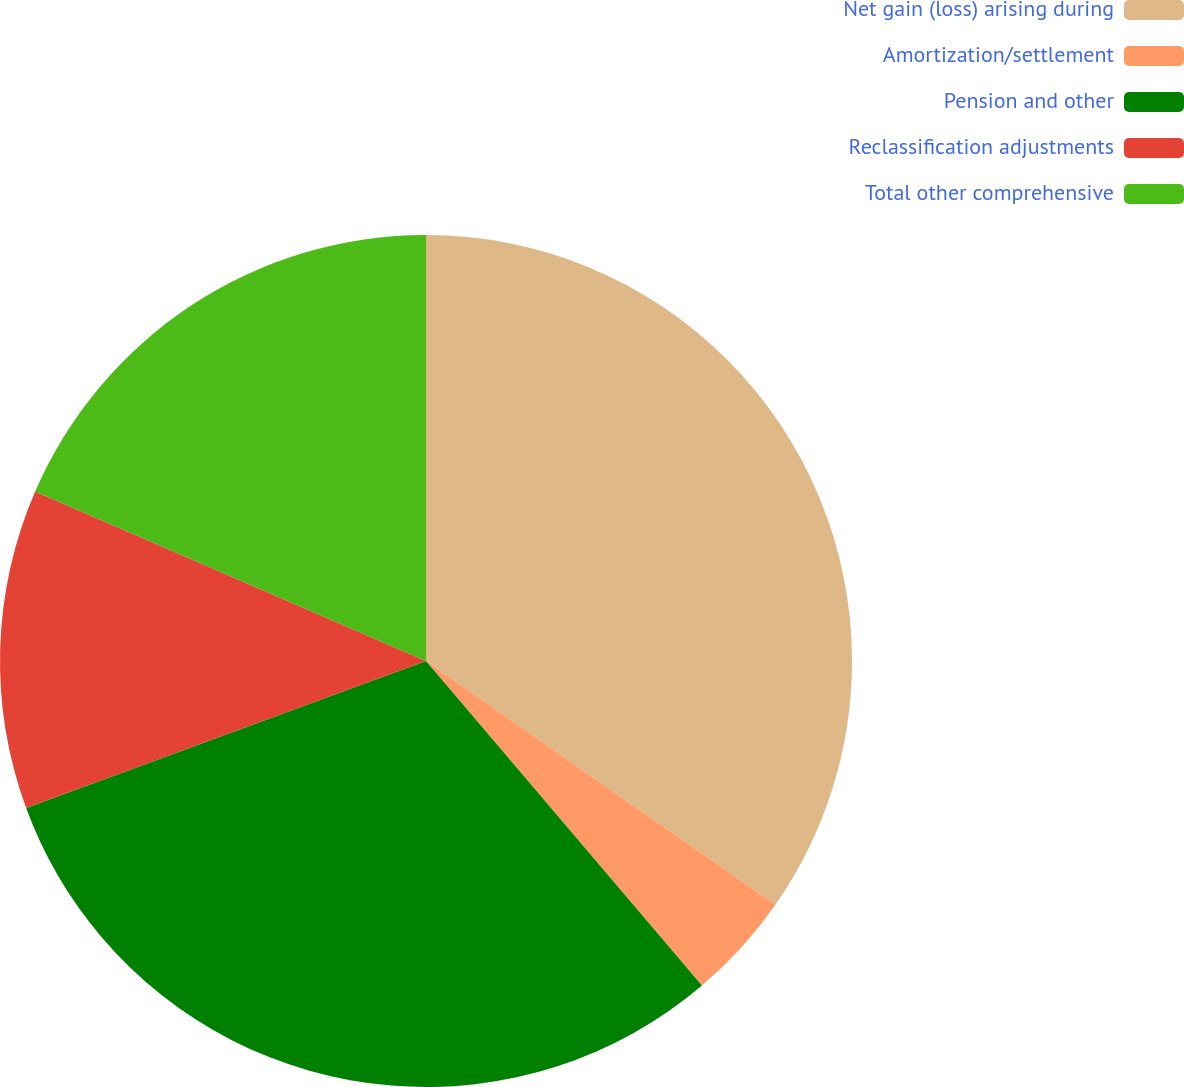<chart> <loc_0><loc_0><loc_500><loc_500><pie_chart><fcel>Net gain (loss) arising during<fcel>Amortization/settlement<fcel>Pension and other<fcel>Reclassification adjustments<fcel>Total other comprehensive<nl><fcel>34.7%<fcel>4.09%<fcel>30.61%<fcel>12.12%<fcel>18.49%<nl></chart> 